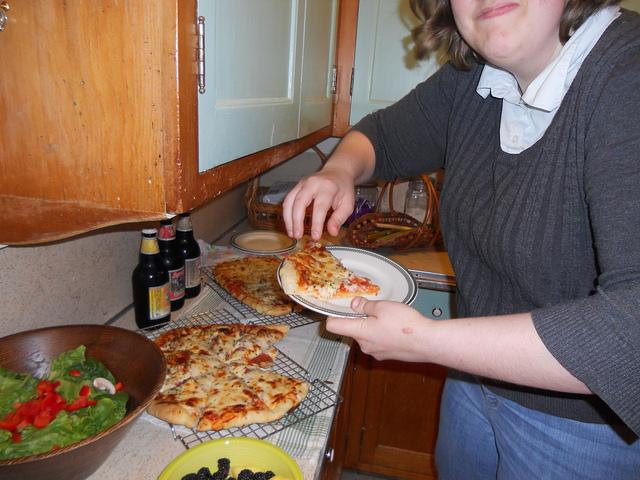What will the woman drink with her pizza?

Choices:
A) milk
B) coke
C) beer
D) wine beer 